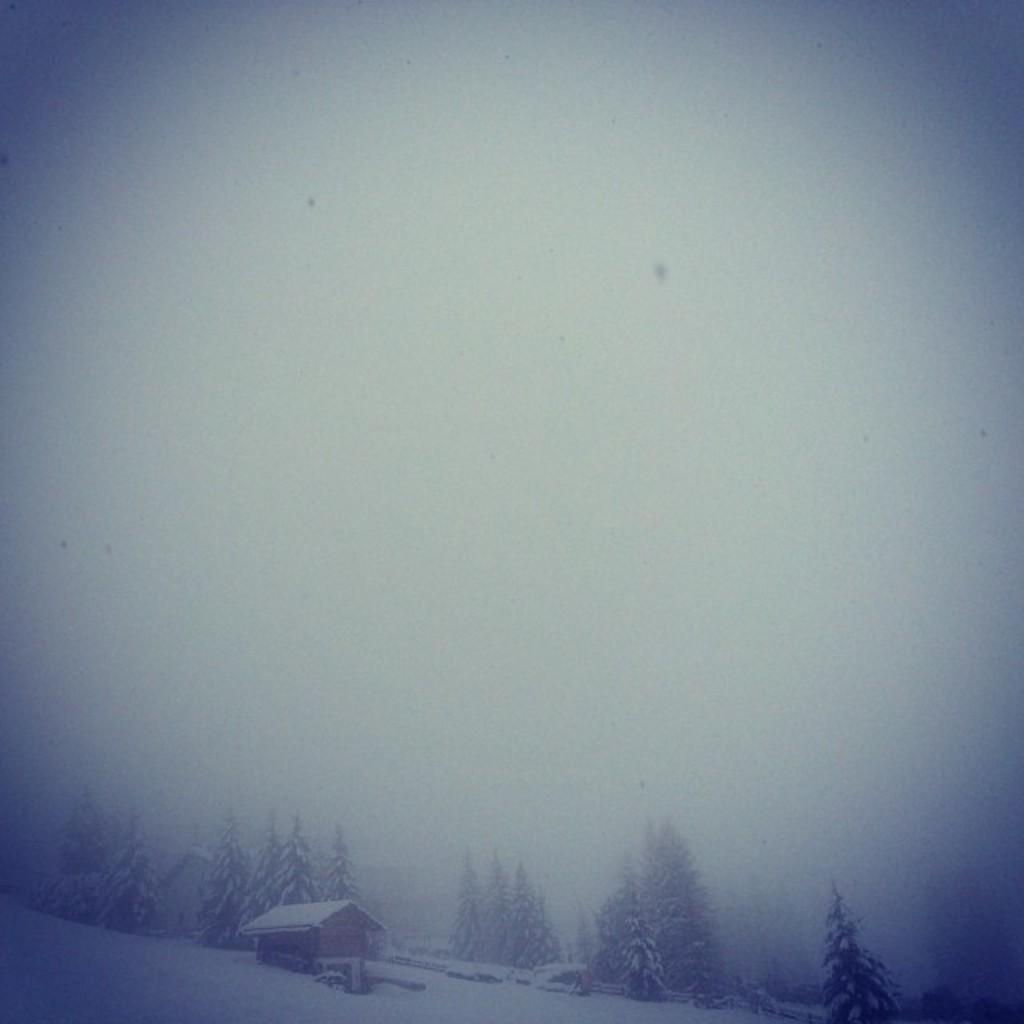Could you give a brief overview of what you see in this image? In this image there is a house, trees and land that are covered with snow. 